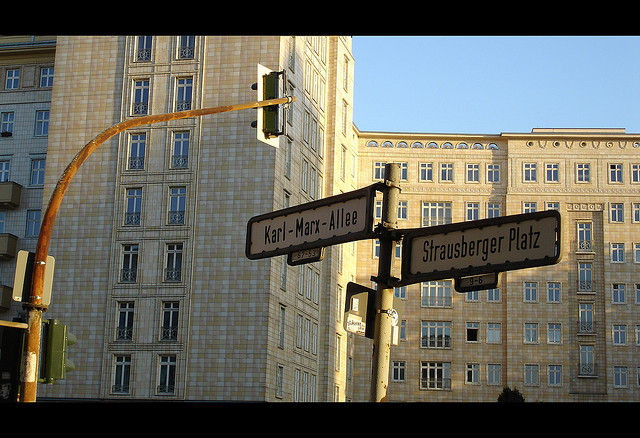<image>What is Boulevard name? I am not sure about the Boulevard's name, but it can be either 'karl marx allee' or 'strausberger platz'. Where is the pattern that looks like a ladder? The pattern that looks like a ladder is unknown. It could be on a building or on windows. What is Boulevard name? I don't know what is the name of the boulevard. It can be either Karl Marx Allee or Strausberger Platz. Where is the pattern that looks like a ladder? It is ambiguous where the pattern that looks like a ladder is. It can be seen on the building or on the windows. 